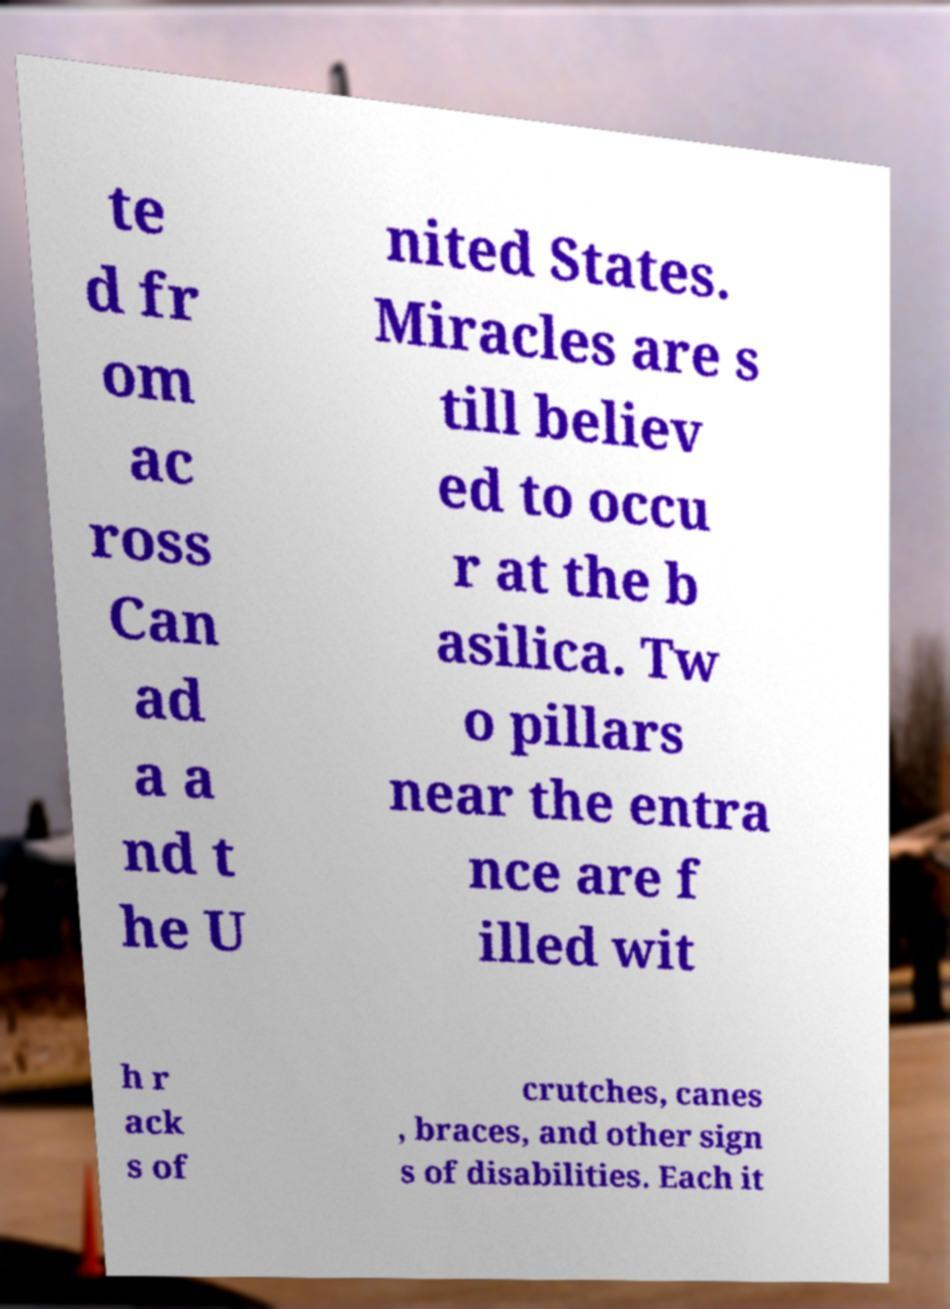Please identify and transcribe the text found in this image. te d fr om ac ross Can ad a a nd t he U nited States. Miracles are s till believ ed to occu r at the b asilica. Tw o pillars near the entra nce are f illed wit h r ack s of crutches, canes , braces, and other sign s of disabilities. Each it 